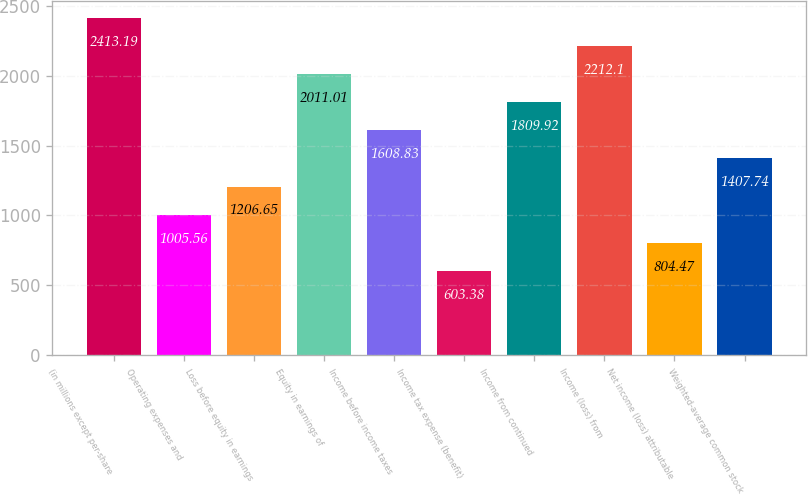<chart> <loc_0><loc_0><loc_500><loc_500><bar_chart><fcel>(in millions except per-share<fcel>Operating expenses and<fcel>Loss before equity in earnings<fcel>Equity in earnings of<fcel>Income before income taxes<fcel>Income tax expense (benefit)<fcel>Income from continued<fcel>Income (loss) from<fcel>Net income (loss) attributable<fcel>Weighted-average common stock<nl><fcel>2413.19<fcel>1005.56<fcel>1206.65<fcel>2011.01<fcel>1608.83<fcel>603.38<fcel>1809.92<fcel>2212.1<fcel>804.47<fcel>1407.74<nl></chart> 